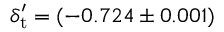<formula> <loc_0><loc_0><loc_500><loc_500>{ \delta _ { t } ^ { \prime } } = ( - 0 . 7 2 4 \pm 0 . 0 0 1 )</formula> 